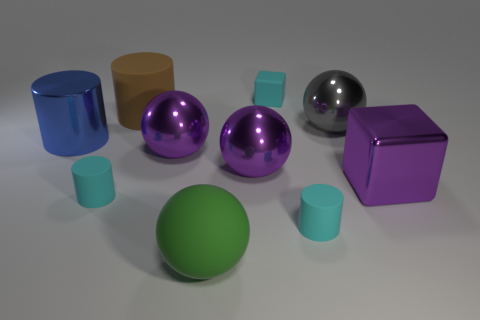Subtract 1 cylinders. How many cylinders are left? 3 Subtract all purple cylinders. Subtract all green cubes. How many cylinders are left? 4 Subtract all cylinders. How many objects are left? 6 Add 7 cyan rubber cylinders. How many cyan rubber cylinders are left? 9 Add 1 matte cylinders. How many matte cylinders exist? 4 Subtract 0 green blocks. How many objects are left? 10 Subtract all rubber cylinders. Subtract all purple shiny cubes. How many objects are left? 6 